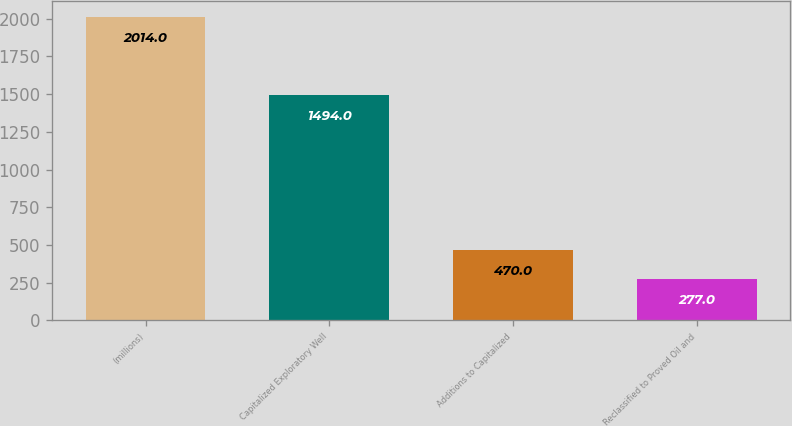Convert chart. <chart><loc_0><loc_0><loc_500><loc_500><bar_chart><fcel>(millions)<fcel>Capitalized Exploratory Well<fcel>Additions to Capitalized<fcel>Reclassified to Proved Oil and<nl><fcel>2014<fcel>1494<fcel>470<fcel>277<nl></chart> 